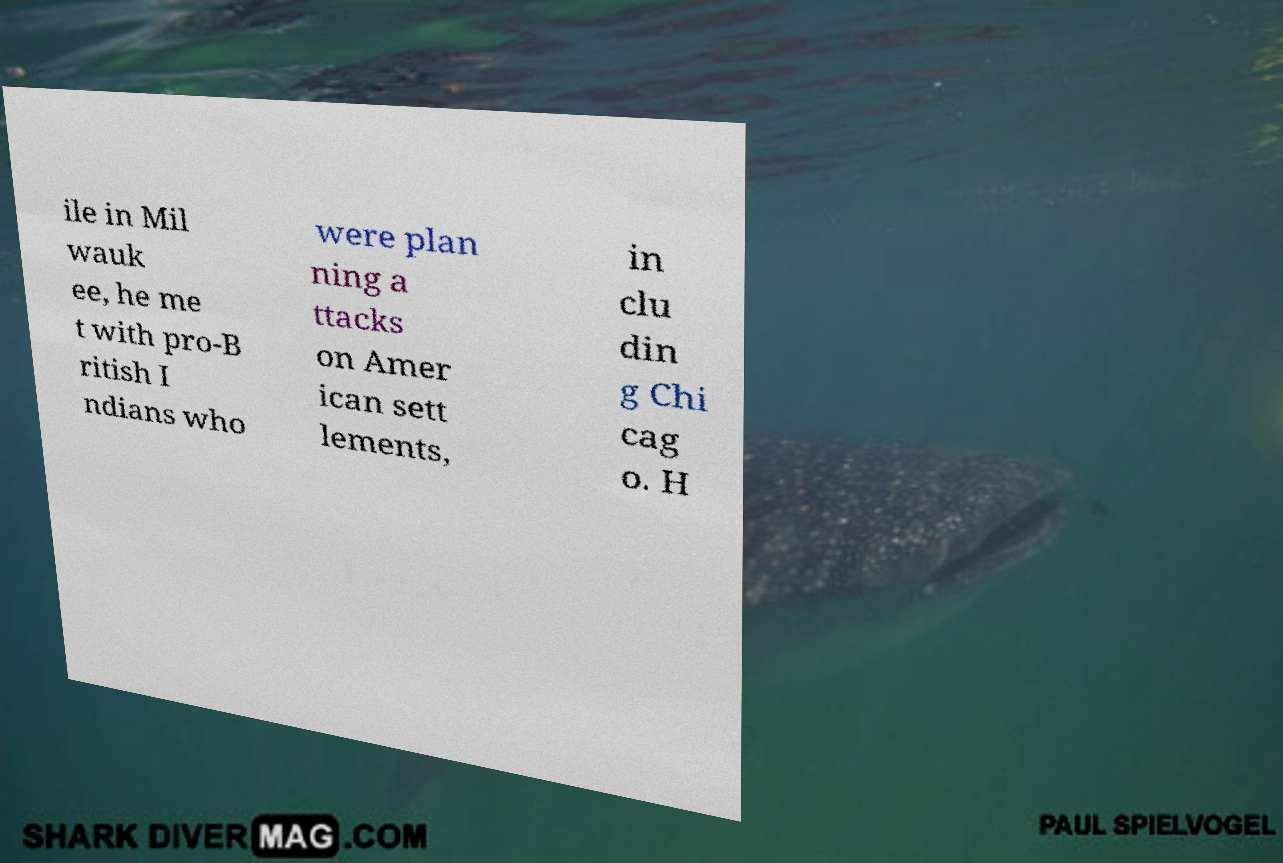What messages or text are displayed in this image? I need them in a readable, typed format. ile in Mil wauk ee, he me t with pro-B ritish I ndians who were plan ning a ttacks on Amer ican sett lements, in clu din g Chi cag o. H 